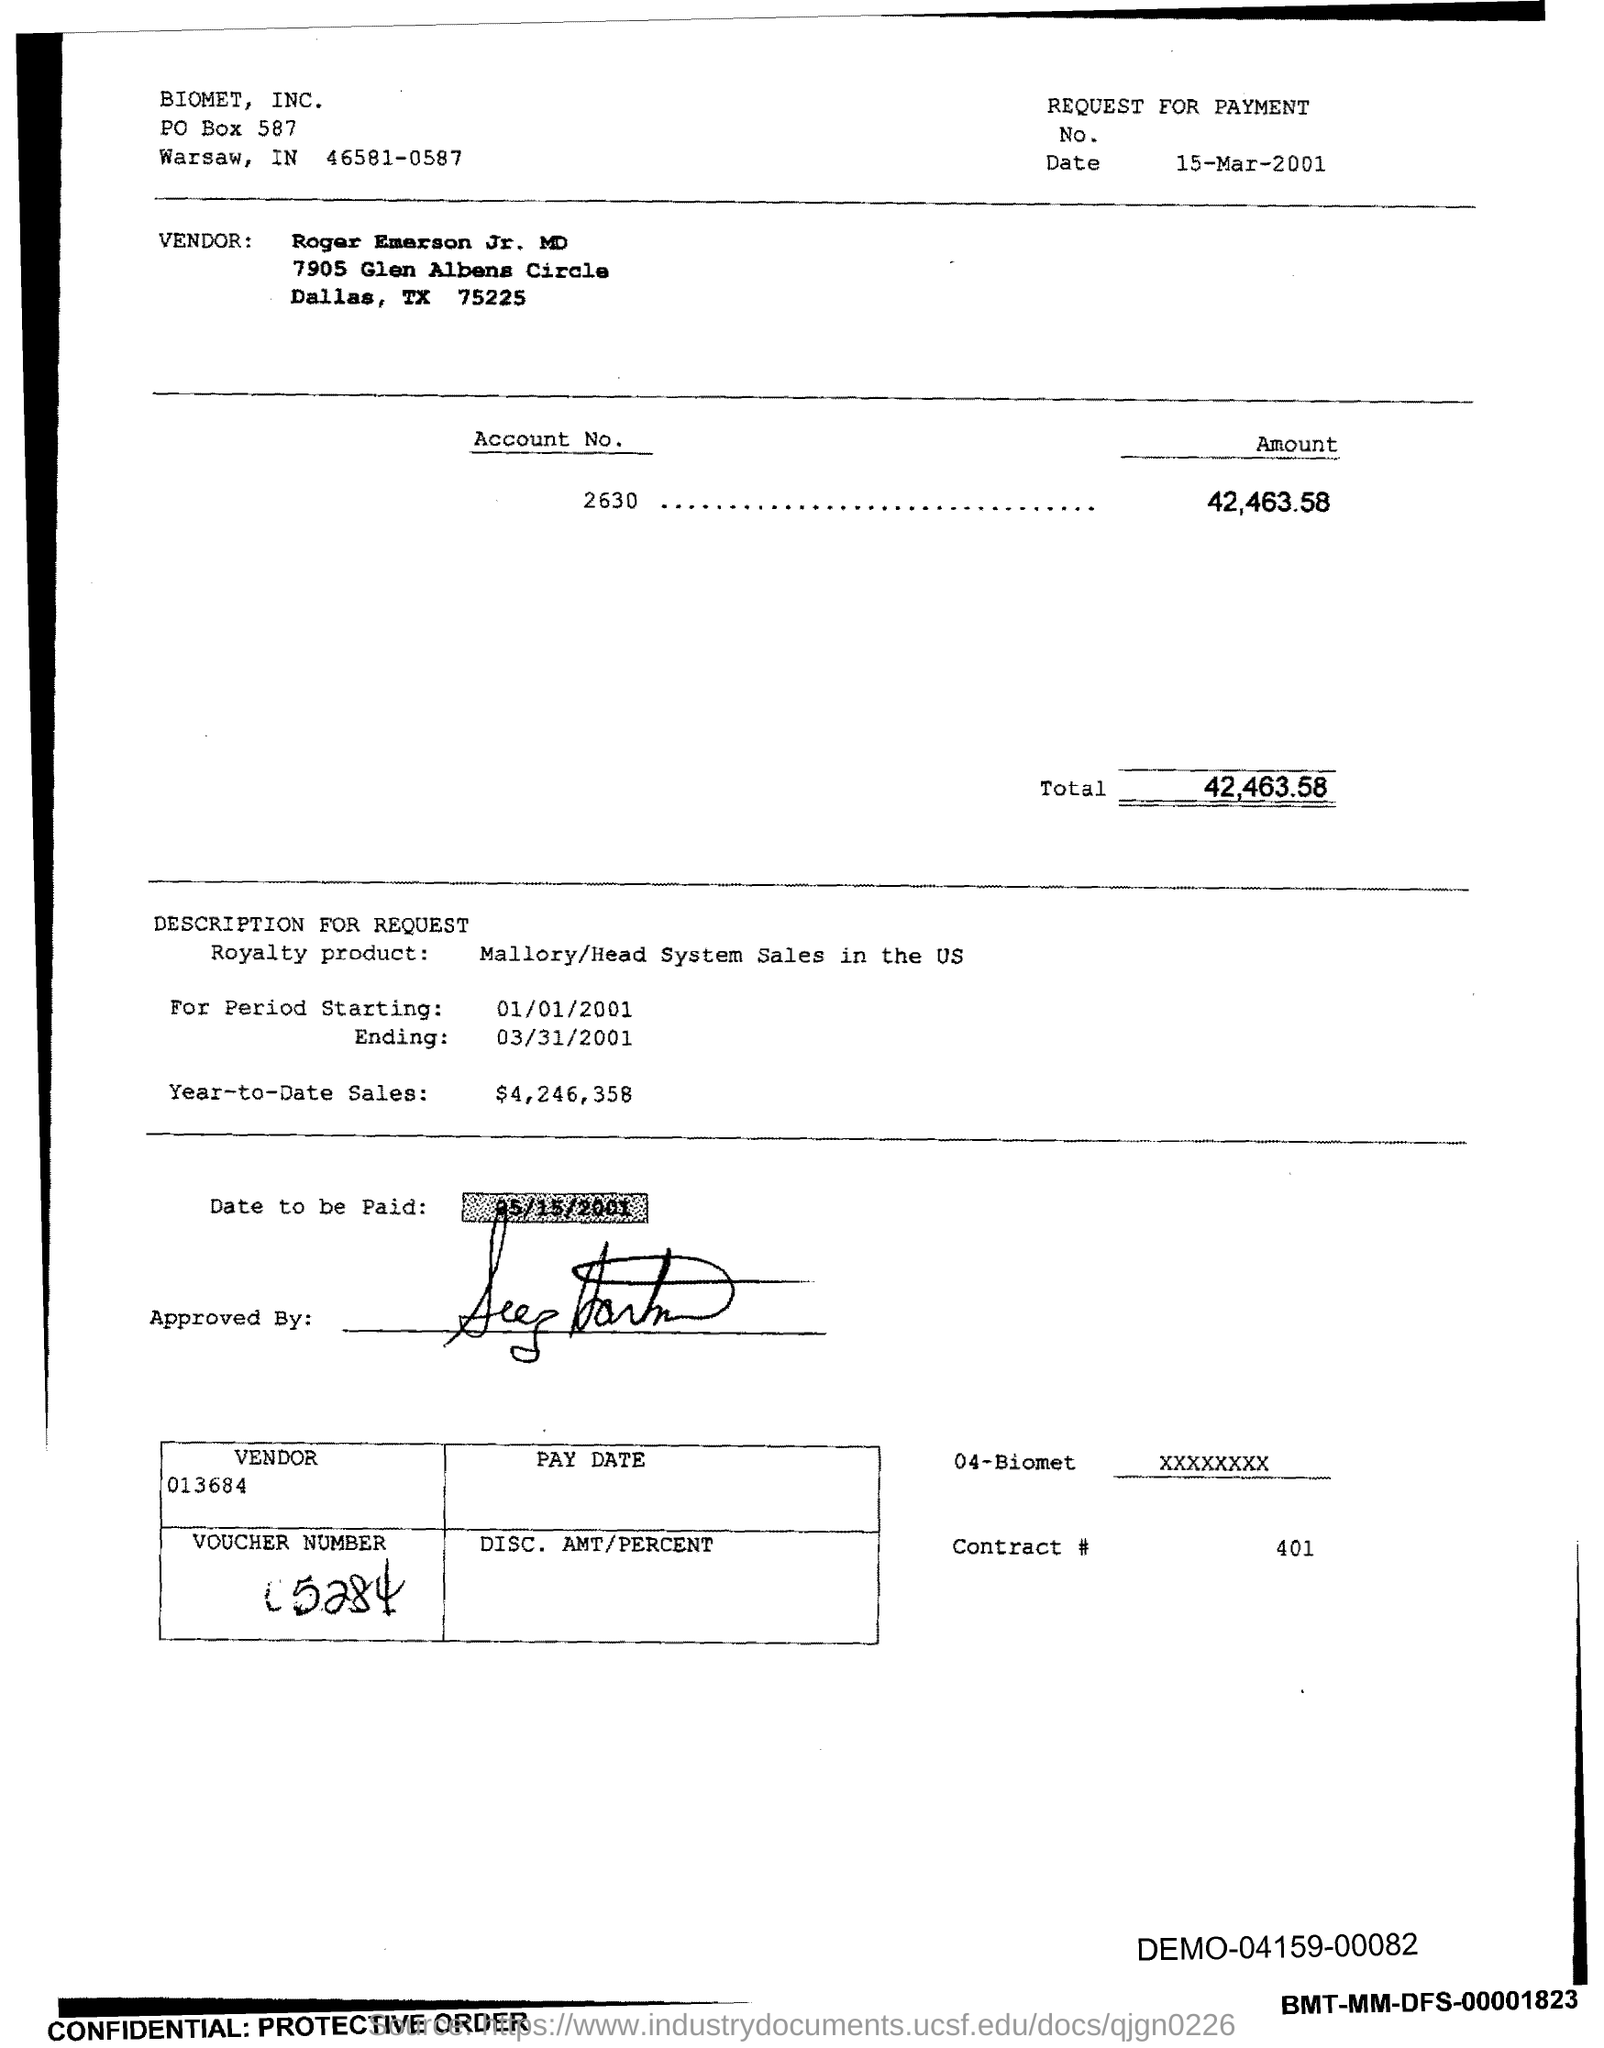Indicate a few pertinent items in this graphic. What is the total amount?" the cashier asked, pointing to the amount displayed on the cash register. The total amount was 42,463.58. The amount for Account No. 2630 is 42,463.58. As of March 15th, 2001, the current date is... The Vendor number is 013684. The year-to-date sales as of March 1, 2023, are $4,246,358. 